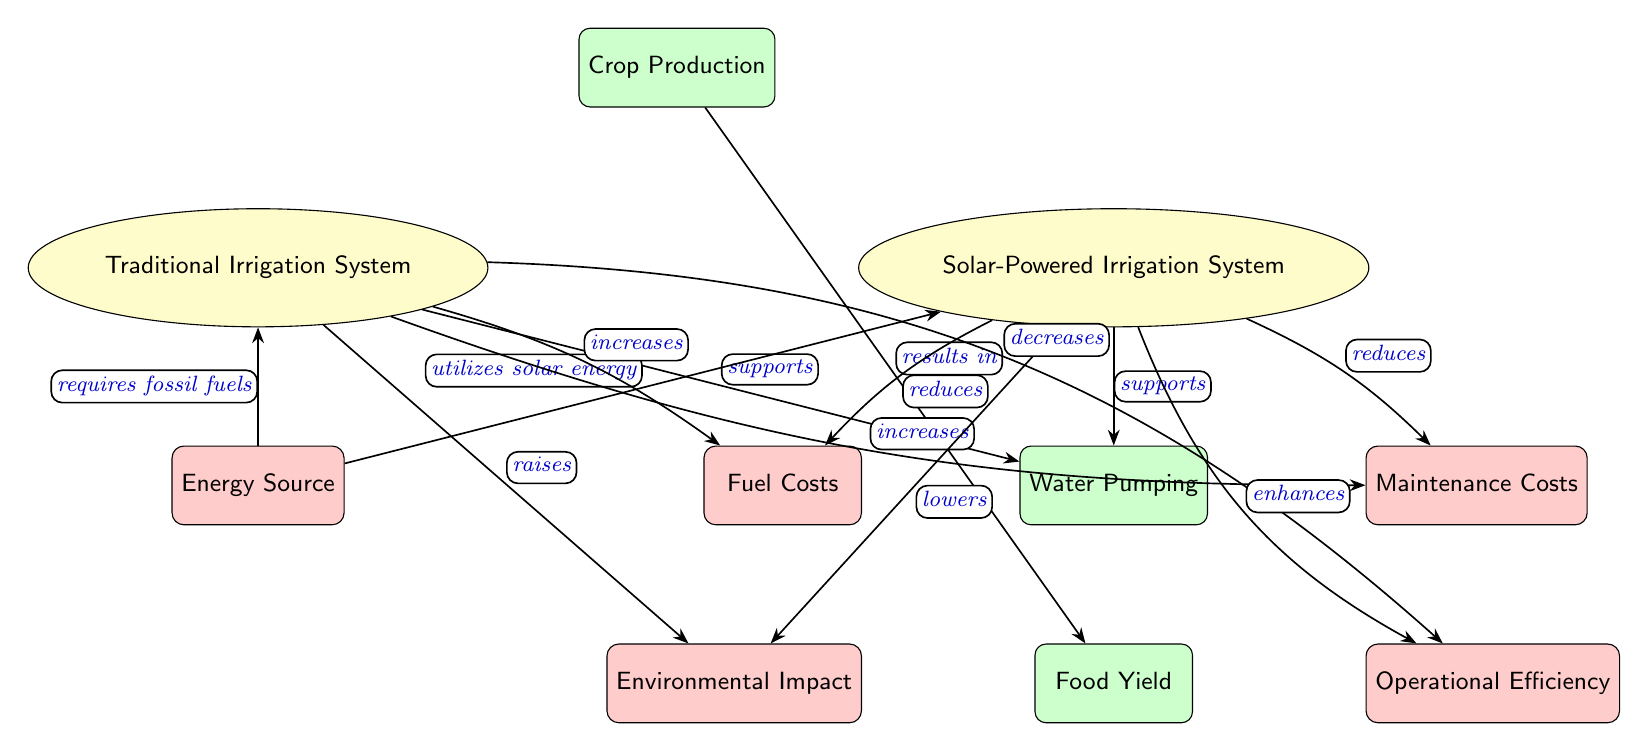What benefits does the solar-powered irrigation system provide compared to the traditional one? The solar-powered irrigation system is designed to utilize solar energy, which reduces fuel and maintenance costs compared to the traditional irrigation system, which relies on fossil fuels. This results in lower environmental impact and enhanced operational efficiency.
Answer: reduces fuel and maintenance costs How many factors affect the traditional irrigation system? There are three factors influencing the traditional irrigation system: Energy Source, Fuel Costs, and Maintenance Costs.
Answer: three What does the traditional irrigation system require? The traditional irrigation system requires fossil fuels as its energy source, as indicated by the edge connecting it to the energy source node.
Answer: fossil fuels How does the solar-powered irrigation system impact environmental factors? The solar-powered irrigation system lowers environmental impact, as depicted by the connection showing its positive effect compared to the traditional system that raises environmental impact.
Answer: lowers Which irrigation system enhances operational efficiency? The solar-powered irrigation system enhances operational efficiency, while the traditional system decreases it, as seen in the connections to the efficiency factor node.
Answer: solar-powered irrigation system What type of system supports food yield? Both the traditional and solar-powered irrigation systems support food yield, as they are both connected to the crop production node and lead to the food yield node.
Answer: both systems Which system has a greater environmental impact? The traditional irrigation system has a greater environmental impact, given its connection indicating it raises the environmental factor, unlike the solar-powered system which lowers it.
Answer: traditional irrigation system What kind of costs does solar-powered irrigation reduce? The solar-powered irrigation system reduces both fuel and maintenance costs, as indicated by the edges that connect it to these cost factors.
Answer: fuel and maintenance costs How many systems are compared in this diagram? The diagram compares two irrigation systems: Traditional Irrigation System and Solar-Powered Irrigation System, clearly represented as separate nodes.
Answer: two 